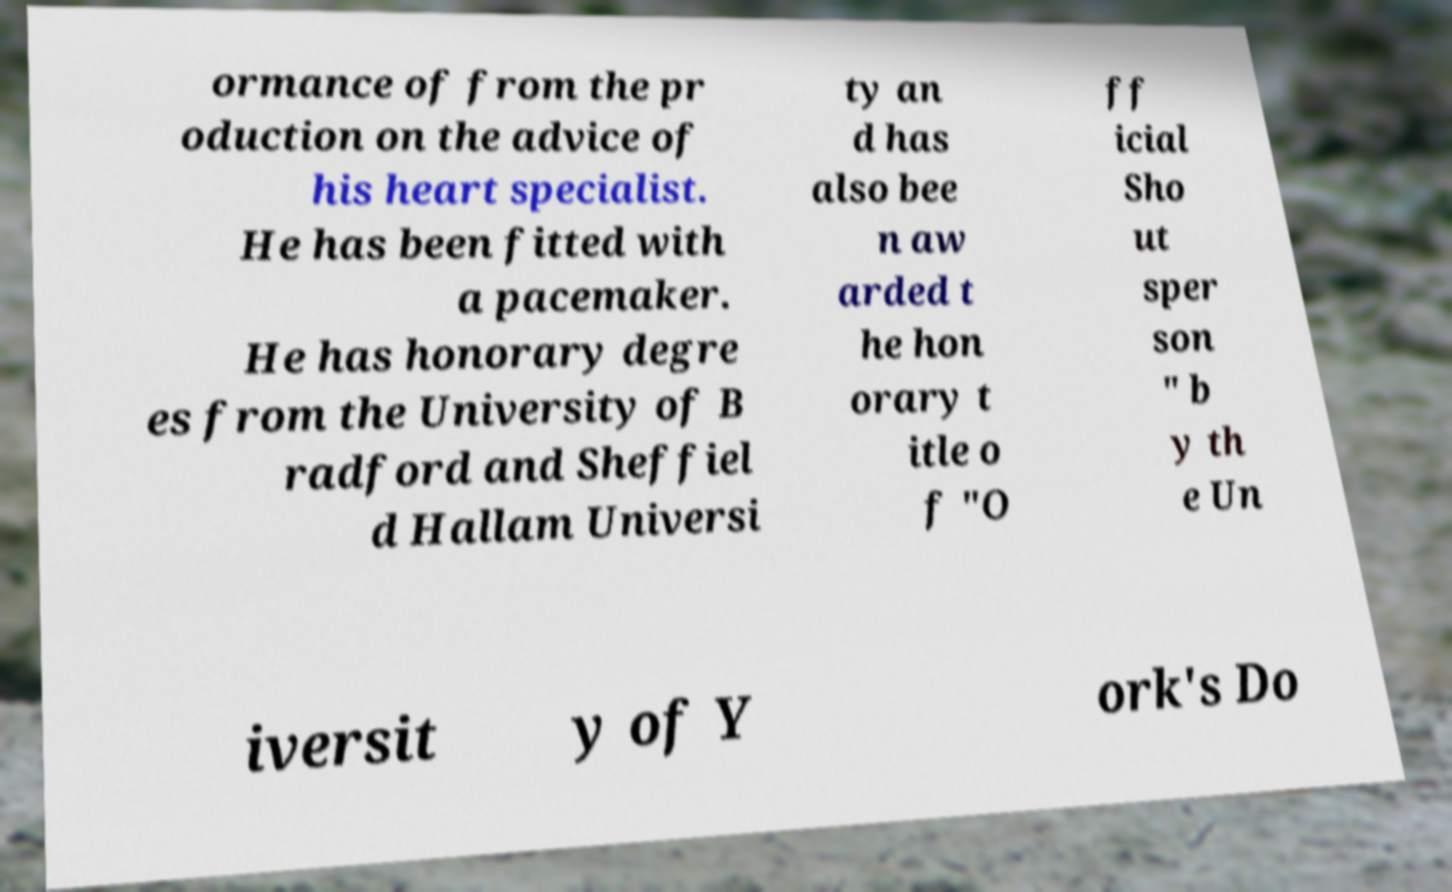What messages or text are displayed in this image? I need them in a readable, typed format. ormance of from the pr oduction on the advice of his heart specialist. He has been fitted with a pacemaker. He has honorary degre es from the University of B radford and Sheffiel d Hallam Universi ty an d has also bee n aw arded t he hon orary t itle o f "O ff icial Sho ut sper son " b y th e Un iversit y of Y ork's Do 